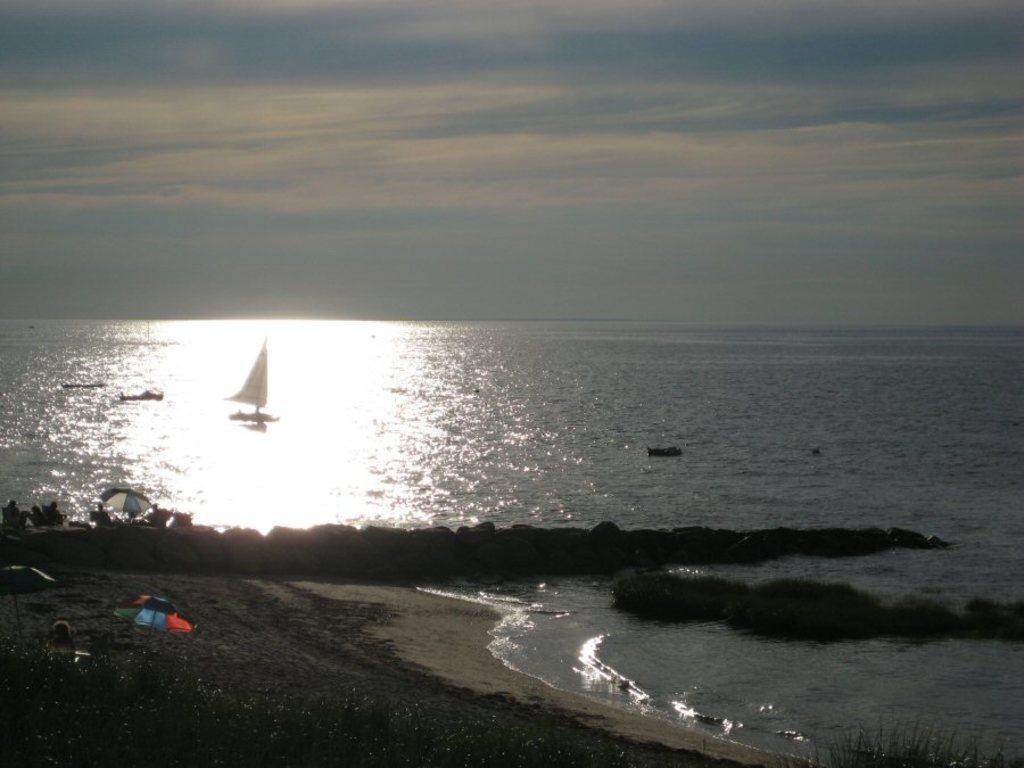Where is the image taken? The image is taken at a sea shore. What can be seen on the shore? There are people and umbrellas on the shore. What is visible on the ocean? There is a boat on the ocean. What type of vegetation is present at the bottom of the image? There are plants at the bottom of the image. What time of day is it in the image, and are there any ants visible? The time of day is not mentioned in the image, and there are no ants visible. Is there a beast roaming on the shore in the image? There is no beast present in the image. 